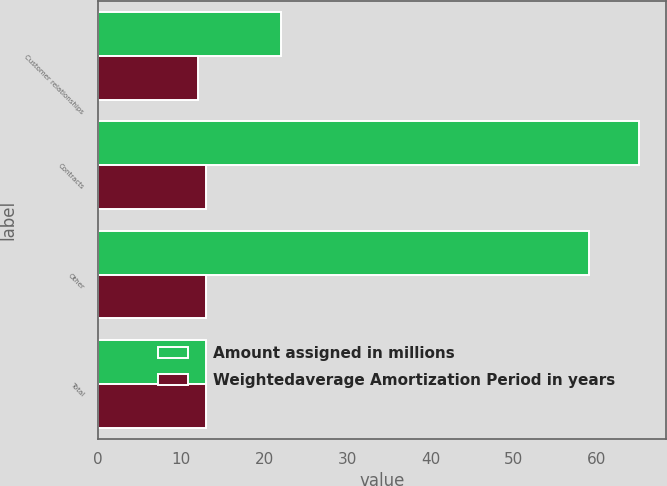Convert chart. <chart><loc_0><loc_0><loc_500><loc_500><stacked_bar_chart><ecel><fcel>Customer relationships<fcel>Contracts<fcel>Other<fcel>Total<nl><fcel>Amount assigned in millions<fcel>22<fcel>65<fcel>59<fcel>13<nl><fcel>Weightedaverage Amortization Period in years<fcel>12<fcel>13<fcel>13<fcel>13<nl></chart> 